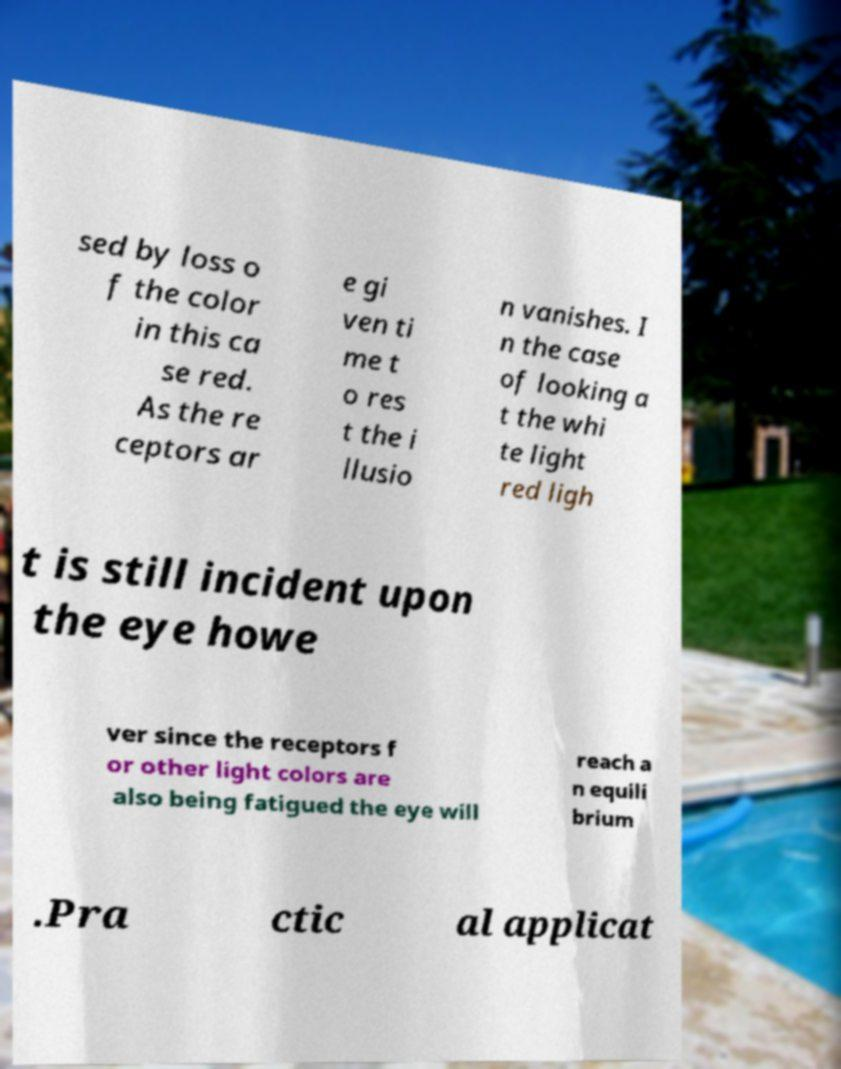Could you extract and type out the text from this image? sed by loss o f the color in this ca se red. As the re ceptors ar e gi ven ti me t o res t the i llusio n vanishes. I n the case of looking a t the whi te light red ligh t is still incident upon the eye howe ver since the receptors f or other light colors are also being fatigued the eye will reach a n equili brium .Pra ctic al applicat 